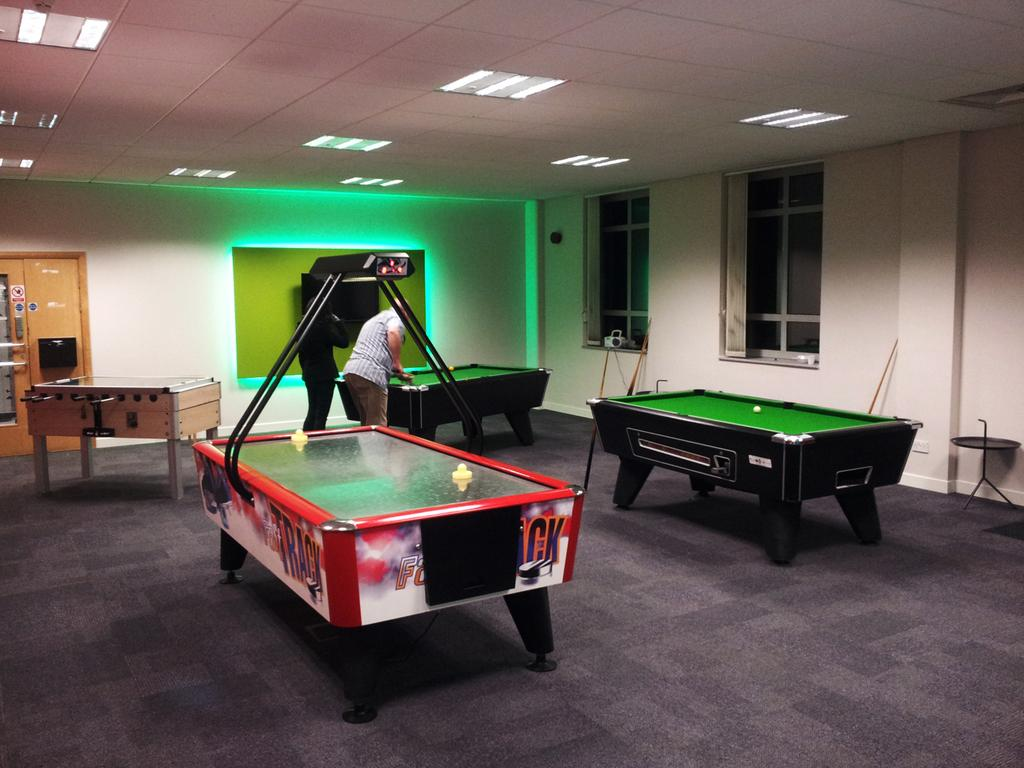What type of table is in the image? There is a snooker table in the image. What equipment is needed to play the game on the table? Snooker sticks are present in the image. How many people are playing the game? Two people are playing the snooker game. Can you describe the positions of the people in the image? There is a person in front of the snooker table, and another person is behind the first person. What can be seen on the ceiling in the image? Lights are attached to the ceiling in the image. What type of door can be seen in the image? There is no door present in the image. What kind of voyage are the people in the image embarking on? There is no indication of a voyage in the image; it shows people playing snooker. 